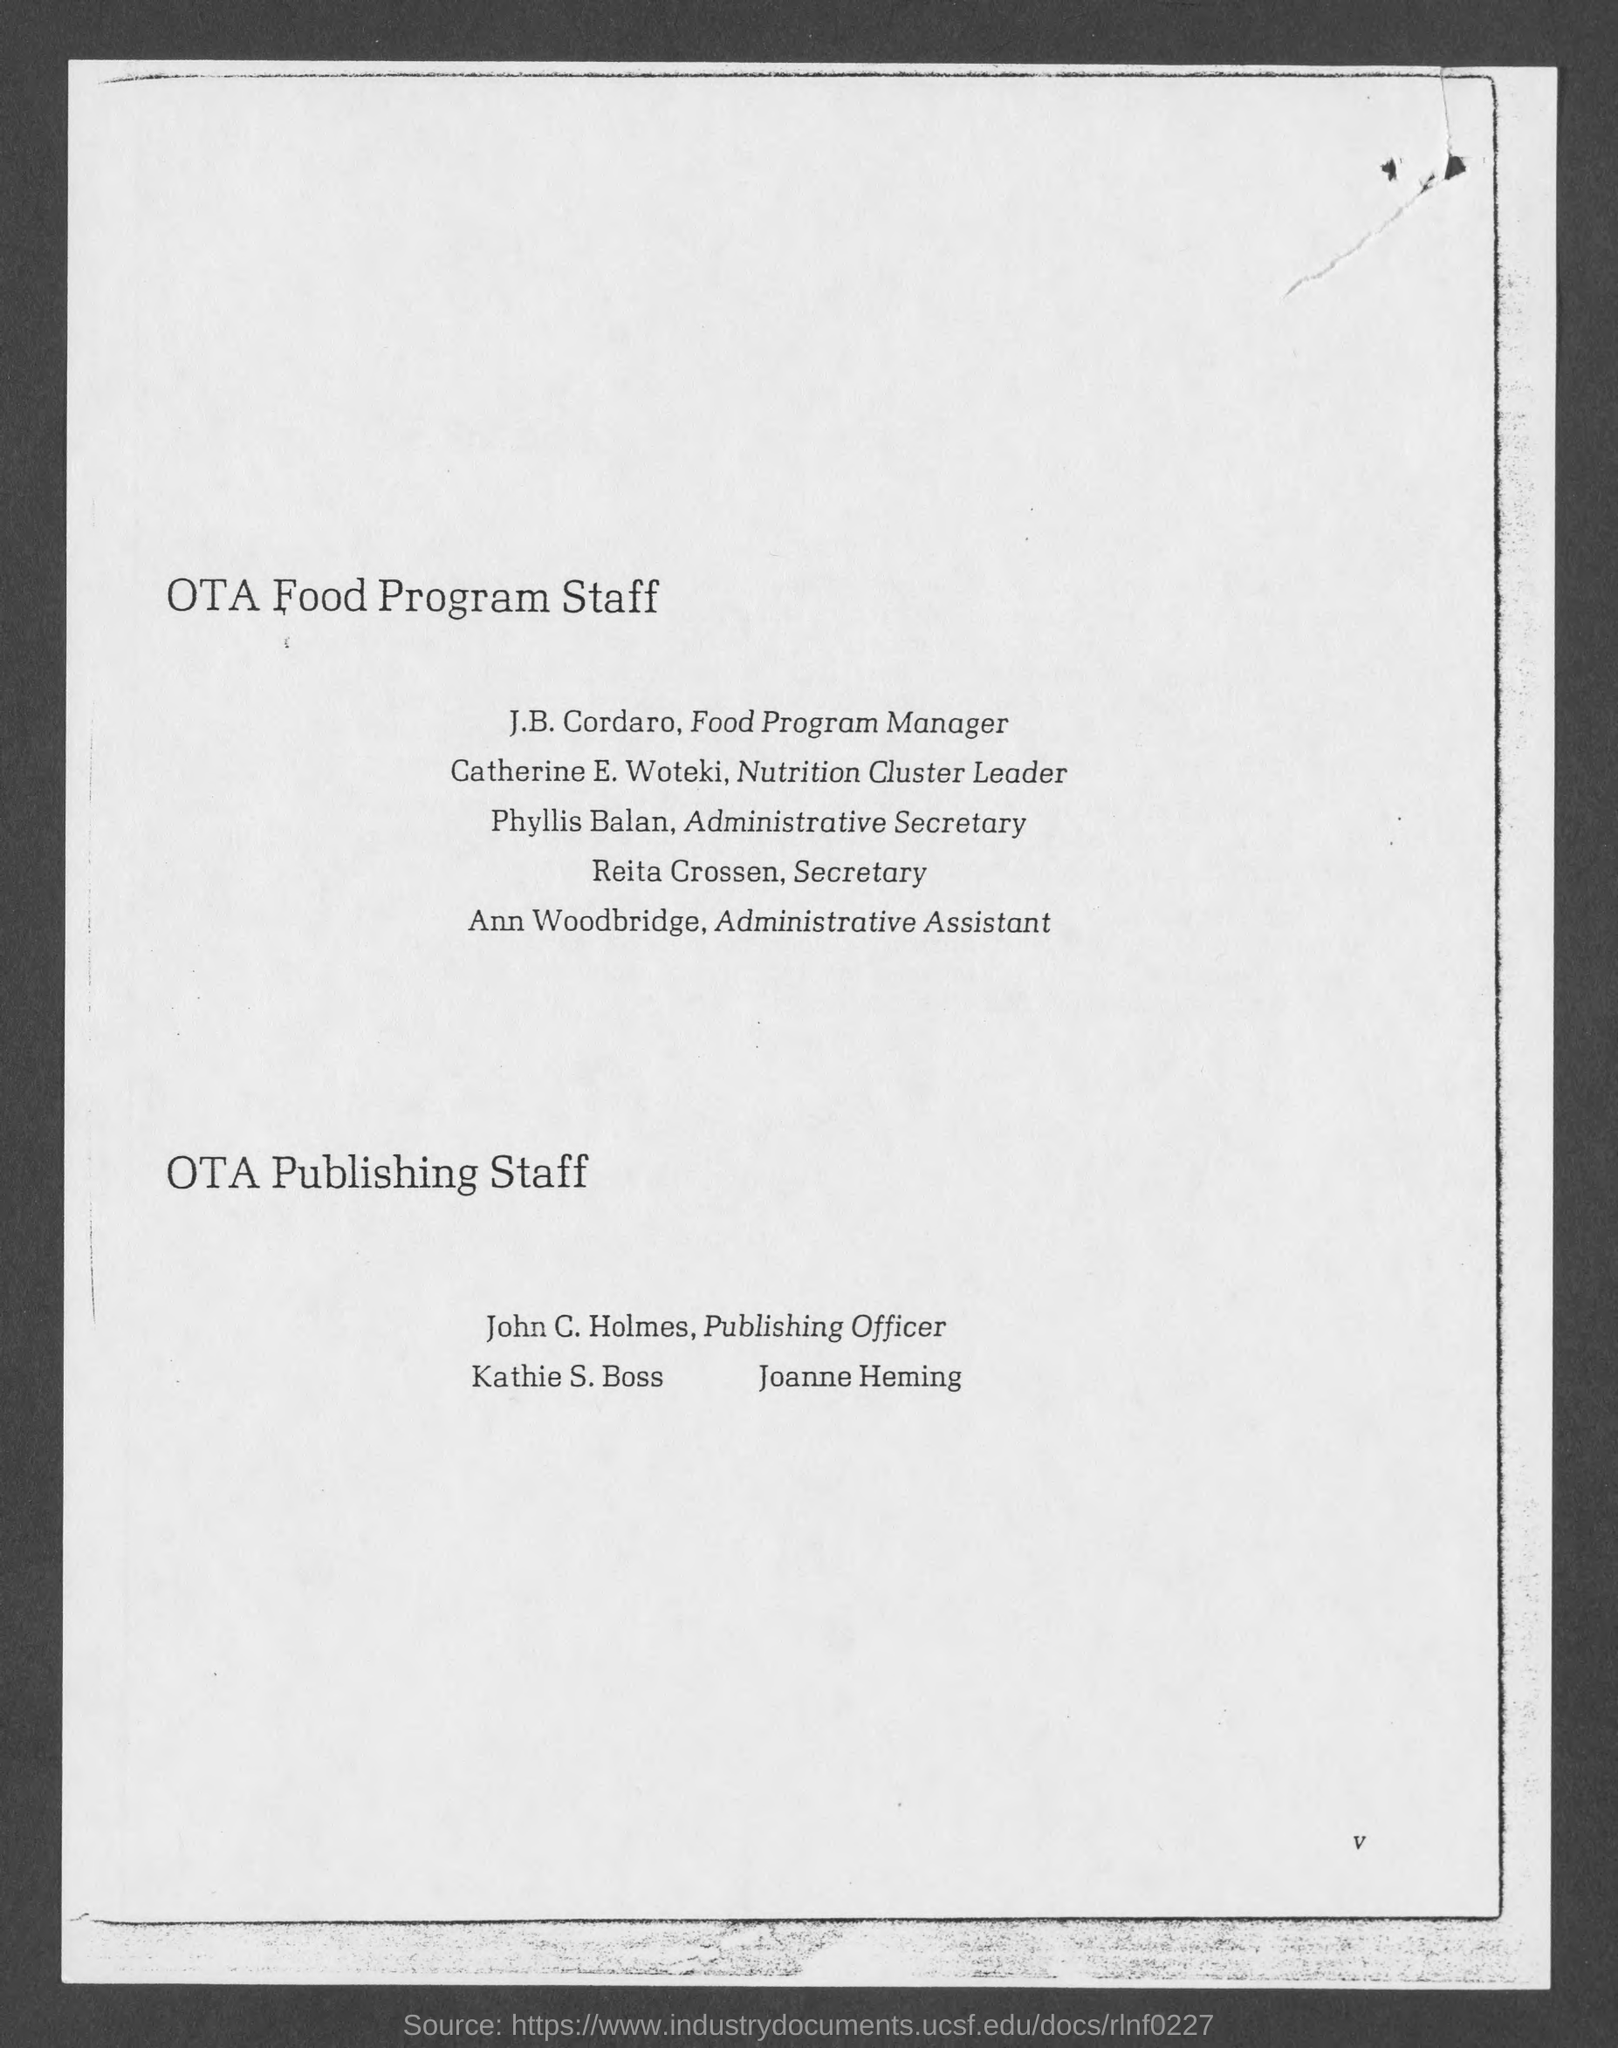Who is the Secretary?
Ensure brevity in your answer.  Reita Crossen. Who is the Administrative Secretary?
Your response must be concise. Phyllis Balan. 